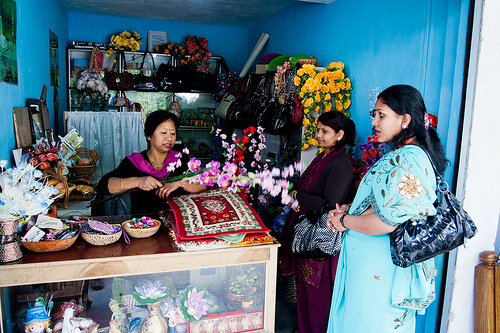<image>
Can you confirm if the rug is on the counter? Yes. Looking at the image, I can see the rug is positioned on top of the counter, with the counter providing support. Where is the yellow flower in relation to the red flower? Is it under the red flower? No. The yellow flower is not positioned under the red flower. The vertical relationship between these objects is different. 